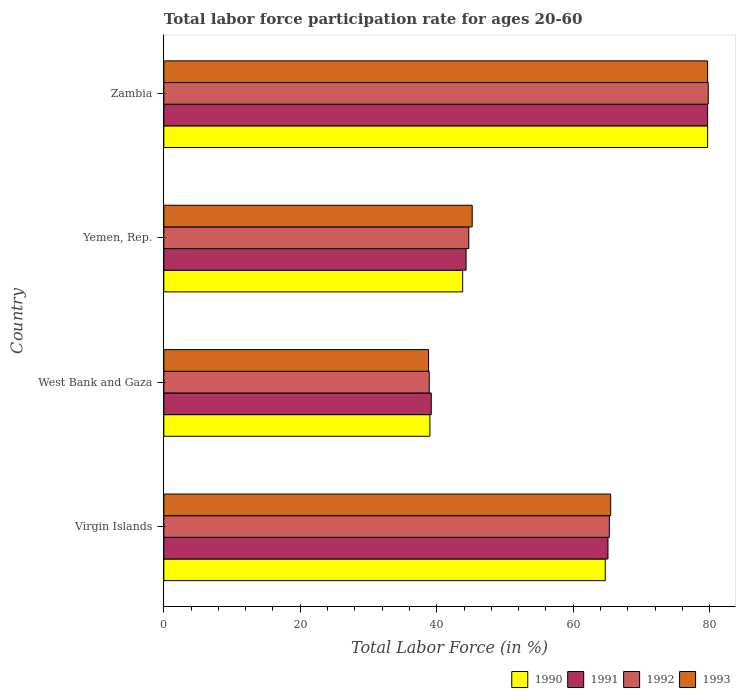Are the number of bars on each tick of the Y-axis equal?
Offer a very short reply. Yes. What is the label of the 1st group of bars from the top?
Keep it short and to the point. Zambia. In how many cases, is the number of bars for a given country not equal to the number of legend labels?
Offer a terse response. 0. What is the labor force participation rate in 1993 in Zambia?
Provide a short and direct response. 79.7. Across all countries, what is the maximum labor force participation rate in 1990?
Make the answer very short. 79.7. Across all countries, what is the minimum labor force participation rate in 1991?
Provide a succinct answer. 39.2. In which country was the labor force participation rate in 1992 maximum?
Your answer should be compact. Zambia. In which country was the labor force participation rate in 1992 minimum?
Offer a very short reply. West Bank and Gaza. What is the total labor force participation rate in 1990 in the graph?
Give a very brief answer. 227.2. What is the difference between the labor force participation rate in 1990 in Virgin Islands and that in Zambia?
Give a very brief answer. -15. What is the difference between the labor force participation rate in 1992 in Virgin Islands and the labor force participation rate in 1993 in Zambia?
Make the answer very short. -14.4. What is the average labor force participation rate in 1991 per country?
Make the answer very short. 57.07. What is the difference between the labor force participation rate in 1991 and labor force participation rate in 1992 in Yemen, Rep.?
Provide a short and direct response. -0.4. What is the ratio of the labor force participation rate in 1990 in Virgin Islands to that in Zambia?
Your answer should be very brief. 0.81. Is the labor force participation rate in 1991 in Yemen, Rep. less than that in Zambia?
Your answer should be compact. Yes. What is the difference between the highest and the second highest labor force participation rate in 1992?
Provide a succinct answer. 14.5. What is the difference between the highest and the lowest labor force participation rate in 1993?
Offer a terse response. 40.9. Is it the case that in every country, the sum of the labor force participation rate in 1991 and labor force participation rate in 1990 is greater than the sum of labor force participation rate in 1993 and labor force participation rate in 1992?
Provide a short and direct response. No. What does the 1st bar from the top in West Bank and Gaza represents?
Offer a terse response. 1993. What does the 2nd bar from the bottom in West Bank and Gaza represents?
Make the answer very short. 1991. What is the difference between two consecutive major ticks on the X-axis?
Your response must be concise. 20. Are the values on the major ticks of X-axis written in scientific E-notation?
Your answer should be compact. No. Does the graph contain any zero values?
Offer a terse response. No. What is the title of the graph?
Your answer should be compact. Total labor force participation rate for ages 20-60. Does "1998" appear as one of the legend labels in the graph?
Make the answer very short. No. What is the label or title of the X-axis?
Your answer should be very brief. Total Labor Force (in %). What is the Total Labor Force (in %) in 1990 in Virgin Islands?
Provide a succinct answer. 64.7. What is the Total Labor Force (in %) in 1991 in Virgin Islands?
Provide a succinct answer. 65.1. What is the Total Labor Force (in %) in 1992 in Virgin Islands?
Keep it short and to the point. 65.3. What is the Total Labor Force (in %) in 1993 in Virgin Islands?
Ensure brevity in your answer.  65.5. What is the Total Labor Force (in %) of 1991 in West Bank and Gaza?
Keep it short and to the point. 39.2. What is the Total Labor Force (in %) of 1992 in West Bank and Gaza?
Provide a short and direct response. 38.9. What is the Total Labor Force (in %) in 1993 in West Bank and Gaza?
Give a very brief answer. 38.8. What is the Total Labor Force (in %) of 1990 in Yemen, Rep.?
Offer a terse response. 43.8. What is the Total Labor Force (in %) in 1991 in Yemen, Rep.?
Provide a short and direct response. 44.3. What is the Total Labor Force (in %) in 1992 in Yemen, Rep.?
Provide a succinct answer. 44.7. What is the Total Labor Force (in %) in 1993 in Yemen, Rep.?
Your answer should be very brief. 45.2. What is the Total Labor Force (in %) of 1990 in Zambia?
Offer a very short reply. 79.7. What is the Total Labor Force (in %) in 1991 in Zambia?
Your response must be concise. 79.7. What is the Total Labor Force (in %) in 1992 in Zambia?
Provide a short and direct response. 79.8. What is the Total Labor Force (in %) of 1993 in Zambia?
Your answer should be compact. 79.7. Across all countries, what is the maximum Total Labor Force (in %) in 1990?
Provide a succinct answer. 79.7. Across all countries, what is the maximum Total Labor Force (in %) of 1991?
Make the answer very short. 79.7. Across all countries, what is the maximum Total Labor Force (in %) of 1992?
Offer a terse response. 79.8. Across all countries, what is the maximum Total Labor Force (in %) of 1993?
Your answer should be very brief. 79.7. Across all countries, what is the minimum Total Labor Force (in %) of 1991?
Offer a terse response. 39.2. Across all countries, what is the minimum Total Labor Force (in %) in 1992?
Offer a terse response. 38.9. Across all countries, what is the minimum Total Labor Force (in %) of 1993?
Your answer should be very brief. 38.8. What is the total Total Labor Force (in %) of 1990 in the graph?
Offer a very short reply. 227.2. What is the total Total Labor Force (in %) of 1991 in the graph?
Offer a terse response. 228.3. What is the total Total Labor Force (in %) in 1992 in the graph?
Provide a short and direct response. 228.7. What is the total Total Labor Force (in %) in 1993 in the graph?
Make the answer very short. 229.2. What is the difference between the Total Labor Force (in %) of 1990 in Virgin Islands and that in West Bank and Gaza?
Provide a succinct answer. 25.7. What is the difference between the Total Labor Force (in %) in 1991 in Virgin Islands and that in West Bank and Gaza?
Your answer should be compact. 25.9. What is the difference between the Total Labor Force (in %) of 1992 in Virgin Islands and that in West Bank and Gaza?
Make the answer very short. 26.4. What is the difference between the Total Labor Force (in %) of 1993 in Virgin Islands and that in West Bank and Gaza?
Give a very brief answer. 26.7. What is the difference between the Total Labor Force (in %) of 1990 in Virgin Islands and that in Yemen, Rep.?
Your answer should be very brief. 20.9. What is the difference between the Total Labor Force (in %) of 1991 in Virgin Islands and that in Yemen, Rep.?
Provide a short and direct response. 20.8. What is the difference between the Total Labor Force (in %) of 1992 in Virgin Islands and that in Yemen, Rep.?
Keep it short and to the point. 20.6. What is the difference between the Total Labor Force (in %) of 1993 in Virgin Islands and that in Yemen, Rep.?
Ensure brevity in your answer.  20.3. What is the difference between the Total Labor Force (in %) in 1990 in Virgin Islands and that in Zambia?
Your answer should be very brief. -15. What is the difference between the Total Labor Force (in %) of 1991 in Virgin Islands and that in Zambia?
Give a very brief answer. -14.6. What is the difference between the Total Labor Force (in %) of 1993 in Virgin Islands and that in Zambia?
Offer a very short reply. -14.2. What is the difference between the Total Labor Force (in %) of 1990 in West Bank and Gaza and that in Yemen, Rep.?
Give a very brief answer. -4.8. What is the difference between the Total Labor Force (in %) of 1991 in West Bank and Gaza and that in Yemen, Rep.?
Your answer should be compact. -5.1. What is the difference between the Total Labor Force (in %) of 1990 in West Bank and Gaza and that in Zambia?
Ensure brevity in your answer.  -40.7. What is the difference between the Total Labor Force (in %) in 1991 in West Bank and Gaza and that in Zambia?
Your response must be concise. -40.5. What is the difference between the Total Labor Force (in %) in 1992 in West Bank and Gaza and that in Zambia?
Ensure brevity in your answer.  -40.9. What is the difference between the Total Labor Force (in %) of 1993 in West Bank and Gaza and that in Zambia?
Make the answer very short. -40.9. What is the difference between the Total Labor Force (in %) in 1990 in Yemen, Rep. and that in Zambia?
Provide a succinct answer. -35.9. What is the difference between the Total Labor Force (in %) of 1991 in Yemen, Rep. and that in Zambia?
Keep it short and to the point. -35.4. What is the difference between the Total Labor Force (in %) of 1992 in Yemen, Rep. and that in Zambia?
Offer a very short reply. -35.1. What is the difference between the Total Labor Force (in %) of 1993 in Yemen, Rep. and that in Zambia?
Your response must be concise. -34.5. What is the difference between the Total Labor Force (in %) of 1990 in Virgin Islands and the Total Labor Force (in %) of 1991 in West Bank and Gaza?
Give a very brief answer. 25.5. What is the difference between the Total Labor Force (in %) in 1990 in Virgin Islands and the Total Labor Force (in %) in 1992 in West Bank and Gaza?
Give a very brief answer. 25.8. What is the difference between the Total Labor Force (in %) of 1990 in Virgin Islands and the Total Labor Force (in %) of 1993 in West Bank and Gaza?
Provide a short and direct response. 25.9. What is the difference between the Total Labor Force (in %) in 1991 in Virgin Islands and the Total Labor Force (in %) in 1992 in West Bank and Gaza?
Your response must be concise. 26.2. What is the difference between the Total Labor Force (in %) in 1991 in Virgin Islands and the Total Labor Force (in %) in 1993 in West Bank and Gaza?
Make the answer very short. 26.3. What is the difference between the Total Labor Force (in %) in 1990 in Virgin Islands and the Total Labor Force (in %) in 1991 in Yemen, Rep.?
Your answer should be compact. 20.4. What is the difference between the Total Labor Force (in %) of 1990 in Virgin Islands and the Total Labor Force (in %) of 1992 in Yemen, Rep.?
Provide a short and direct response. 20. What is the difference between the Total Labor Force (in %) in 1991 in Virgin Islands and the Total Labor Force (in %) in 1992 in Yemen, Rep.?
Your response must be concise. 20.4. What is the difference between the Total Labor Force (in %) of 1992 in Virgin Islands and the Total Labor Force (in %) of 1993 in Yemen, Rep.?
Give a very brief answer. 20.1. What is the difference between the Total Labor Force (in %) of 1990 in Virgin Islands and the Total Labor Force (in %) of 1991 in Zambia?
Make the answer very short. -15. What is the difference between the Total Labor Force (in %) of 1990 in Virgin Islands and the Total Labor Force (in %) of 1992 in Zambia?
Provide a succinct answer. -15.1. What is the difference between the Total Labor Force (in %) of 1991 in Virgin Islands and the Total Labor Force (in %) of 1992 in Zambia?
Give a very brief answer. -14.7. What is the difference between the Total Labor Force (in %) in 1991 in Virgin Islands and the Total Labor Force (in %) in 1993 in Zambia?
Your answer should be very brief. -14.6. What is the difference between the Total Labor Force (in %) of 1992 in Virgin Islands and the Total Labor Force (in %) of 1993 in Zambia?
Provide a succinct answer. -14.4. What is the difference between the Total Labor Force (in %) in 1990 in West Bank and Gaza and the Total Labor Force (in %) in 1991 in Yemen, Rep.?
Make the answer very short. -5.3. What is the difference between the Total Labor Force (in %) in 1990 in West Bank and Gaza and the Total Labor Force (in %) in 1993 in Yemen, Rep.?
Offer a very short reply. -6.2. What is the difference between the Total Labor Force (in %) in 1992 in West Bank and Gaza and the Total Labor Force (in %) in 1993 in Yemen, Rep.?
Give a very brief answer. -6.3. What is the difference between the Total Labor Force (in %) of 1990 in West Bank and Gaza and the Total Labor Force (in %) of 1991 in Zambia?
Offer a terse response. -40.7. What is the difference between the Total Labor Force (in %) in 1990 in West Bank and Gaza and the Total Labor Force (in %) in 1992 in Zambia?
Your answer should be compact. -40.8. What is the difference between the Total Labor Force (in %) in 1990 in West Bank and Gaza and the Total Labor Force (in %) in 1993 in Zambia?
Keep it short and to the point. -40.7. What is the difference between the Total Labor Force (in %) of 1991 in West Bank and Gaza and the Total Labor Force (in %) of 1992 in Zambia?
Your answer should be very brief. -40.6. What is the difference between the Total Labor Force (in %) in 1991 in West Bank and Gaza and the Total Labor Force (in %) in 1993 in Zambia?
Give a very brief answer. -40.5. What is the difference between the Total Labor Force (in %) in 1992 in West Bank and Gaza and the Total Labor Force (in %) in 1993 in Zambia?
Provide a short and direct response. -40.8. What is the difference between the Total Labor Force (in %) of 1990 in Yemen, Rep. and the Total Labor Force (in %) of 1991 in Zambia?
Your answer should be very brief. -35.9. What is the difference between the Total Labor Force (in %) of 1990 in Yemen, Rep. and the Total Labor Force (in %) of 1992 in Zambia?
Give a very brief answer. -36. What is the difference between the Total Labor Force (in %) of 1990 in Yemen, Rep. and the Total Labor Force (in %) of 1993 in Zambia?
Give a very brief answer. -35.9. What is the difference between the Total Labor Force (in %) in 1991 in Yemen, Rep. and the Total Labor Force (in %) in 1992 in Zambia?
Your answer should be compact. -35.5. What is the difference between the Total Labor Force (in %) of 1991 in Yemen, Rep. and the Total Labor Force (in %) of 1993 in Zambia?
Offer a terse response. -35.4. What is the difference between the Total Labor Force (in %) in 1992 in Yemen, Rep. and the Total Labor Force (in %) in 1993 in Zambia?
Make the answer very short. -35. What is the average Total Labor Force (in %) of 1990 per country?
Offer a very short reply. 56.8. What is the average Total Labor Force (in %) of 1991 per country?
Provide a succinct answer. 57.08. What is the average Total Labor Force (in %) in 1992 per country?
Your answer should be very brief. 57.17. What is the average Total Labor Force (in %) of 1993 per country?
Give a very brief answer. 57.3. What is the difference between the Total Labor Force (in %) of 1990 and Total Labor Force (in %) of 1991 in Virgin Islands?
Provide a succinct answer. -0.4. What is the difference between the Total Labor Force (in %) of 1990 and Total Labor Force (in %) of 1992 in Virgin Islands?
Offer a terse response. -0.6. What is the difference between the Total Labor Force (in %) in 1990 and Total Labor Force (in %) in 1991 in West Bank and Gaza?
Provide a short and direct response. -0.2. What is the difference between the Total Labor Force (in %) in 1990 and Total Labor Force (in %) in 1993 in West Bank and Gaza?
Your answer should be compact. 0.2. What is the difference between the Total Labor Force (in %) of 1991 and Total Labor Force (in %) of 1993 in West Bank and Gaza?
Provide a short and direct response. 0.4. What is the difference between the Total Labor Force (in %) of 1990 and Total Labor Force (in %) of 1991 in Yemen, Rep.?
Make the answer very short. -0.5. What is the difference between the Total Labor Force (in %) in 1990 and Total Labor Force (in %) in 1993 in Yemen, Rep.?
Provide a succinct answer. -1.4. What is the difference between the Total Labor Force (in %) in 1991 and Total Labor Force (in %) in 1992 in Yemen, Rep.?
Make the answer very short. -0.4. What is the difference between the Total Labor Force (in %) of 1991 and Total Labor Force (in %) of 1993 in Yemen, Rep.?
Your answer should be very brief. -0.9. What is the difference between the Total Labor Force (in %) of 1992 and Total Labor Force (in %) of 1993 in Yemen, Rep.?
Offer a very short reply. -0.5. What is the difference between the Total Labor Force (in %) in 1990 and Total Labor Force (in %) in 1992 in Zambia?
Keep it short and to the point. -0.1. What is the difference between the Total Labor Force (in %) in 1992 and Total Labor Force (in %) in 1993 in Zambia?
Give a very brief answer. 0.1. What is the ratio of the Total Labor Force (in %) of 1990 in Virgin Islands to that in West Bank and Gaza?
Your response must be concise. 1.66. What is the ratio of the Total Labor Force (in %) in 1991 in Virgin Islands to that in West Bank and Gaza?
Provide a succinct answer. 1.66. What is the ratio of the Total Labor Force (in %) of 1992 in Virgin Islands to that in West Bank and Gaza?
Offer a terse response. 1.68. What is the ratio of the Total Labor Force (in %) in 1993 in Virgin Islands to that in West Bank and Gaza?
Your answer should be very brief. 1.69. What is the ratio of the Total Labor Force (in %) of 1990 in Virgin Islands to that in Yemen, Rep.?
Your response must be concise. 1.48. What is the ratio of the Total Labor Force (in %) of 1991 in Virgin Islands to that in Yemen, Rep.?
Keep it short and to the point. 1.47. What is the ratio of the Total Labor Force (in %) in 1992 in Virgin Islands to that in Yemen, Rep.?
Offer a very short reply. 1.46. What is the ratio of the Total Labor Force (in %) of 1993 in Virgin Islands to that in Yemen, Rep.?
Your answer should be very brief. 1.45. What is the ratio of the Total Labor Force (in %) in 1990 in Virgin Islands to that in Zambia?
Offer a very short reply. 0.81. What is the ratio of the Total Labor Force (in %) of 1991 in Virgin Islands to that in Zambia?
Make the answer very short. 0.82. What is the ratio of the Total Labor Force (in %) of 1992 in Virgin Islands to that in Zambia?
Provide a succinct answer. 0.82. What is the ratio of the Total Labor Force (in %) in 1993 in Virgin Islands to that in Zambia?
Your answer should be compact. 0.82. What is the ratio of the Total Labor Force (in %) in 1990 in West Bank and Gaza to that in Yemen, Rep.?
Provide a short and direct response. 0.89. What is the ratio of the Total Labor Force (in %) in 1991 in West Bank and Gaza to that in Yemen, Rep.?
Keep it short and to the point. 0.88. What is the ratio of the Total Labor Force (in %) of 1992 in West Bank and Gaza to that in Yemen, Rep.?
Your response must be concise. 0.87. What is the ratio of the Total Labor Force (in %) in 1993 in West Bank and Gaza to that in Yemen, Rep.?
Keep it short and to the point. 0.86. What is the ratio of the Total Labor Force (in %) of 1990 in West Bank and Gaza to that in Zambia?
Keep it short and to the point. 0.49. What is the ratio of the Total Labor Force (in %) in 1991 in West Bank and Gaza to that in Zambia?
Keep it short and to the point. 0.49. What is the ratio of the Total Labor Force (in %) in 1992 in West Bank and Gaza to that in Zambia?
Give a very brief answer. 0.49. What is the ratio of the Total Labor Force (in %) in 1993 in West Bank and Gaza to that in Zambia?
Make the answer very short. 0.49. What is the ratio of the Total Labor Force (in %) in 1990 in Yemen, Rep. to that in Zambia?
Your response must be concise. 0.55. What is the ratio of the Total Labor Force (in %) in 1991 in Yemen, Rep. to that in Zambia?
Your answer should be very brief. 0.56. What is the ratio of the Total Labor Force (in %) in 1992 in Yemen, Rep. to that in Zambia?
Your answer should be very brief. 0.56. What is the ratio of the Total Labor Force (in %) in 1993 in Yemen, Rep. to that in Zambia?
Your response must be concise. 0.57. What is the difference between the highest and the second highest Total Labor Force (in %) in 1991?
Offer a terse response. 14.6. What is the difference between the highest and the second highest Total Labor Force (in %) in 1992?
Give a very brief answer. 14.5. What is the difference between the highest and the second highest Total Labor Force (in %) in 1993?
Give a very brief answer. 14.2. What is the difference between the highest and the lowest Total Labor Force (in %) of 1990?
Provide a succinct answer. 40.7. What is the difference between the highest and the lowest Total Labor Force (in %) in 1991?
Keep it short and to the point. 40.5. What is the difference between the highest and the lowest Total Labor Force (in %) of 1992?
Provide a short and direct response. 40.9. What is the difference between the highest and the lowest Total Labor Force (in %) in 1993?
Keep it short and to the point. 40.9. 